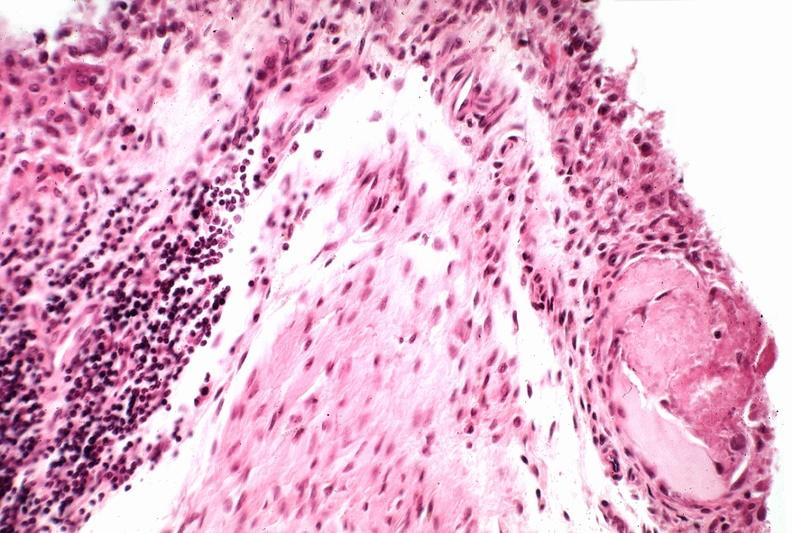does normal show synovial proliferation, villous, rheumatoid arthritis?
Answer the question using a single word or phrase. No 